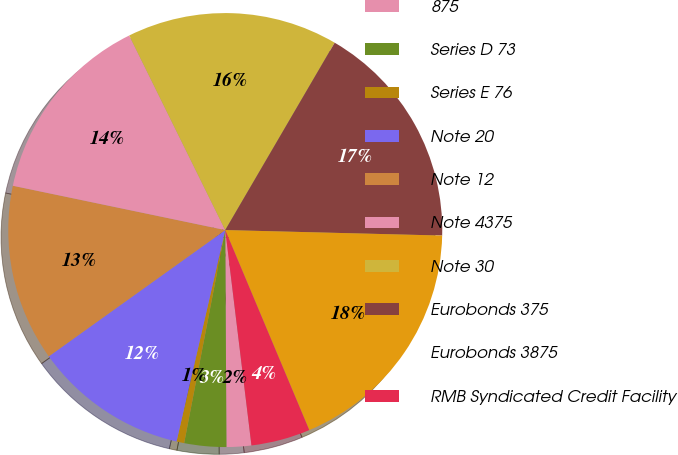Convert chart to OTSL. <chart><loc_0><loc_0><loc_500><loc_500><pie_chart><fcel>875<fcel>Series D 73<fcel>Series E 76<fcel>Note 20<fcel>Note 12<fcel>Note 4375<fcel>Note 30<fcel>Eurobonds 375<fcel>Eurobonds 3875<fcel>RMB Syndicated Credit Facility<nl><fcel>1.84%<fcel>3.12%<fcel>0.57%<fcel>11.51%<fcel>13.16%<fcel>14.43%<fcel>15.71%<fcel>16.99%<fcel>18.27%<fcel>4.4%<nl></chart> 